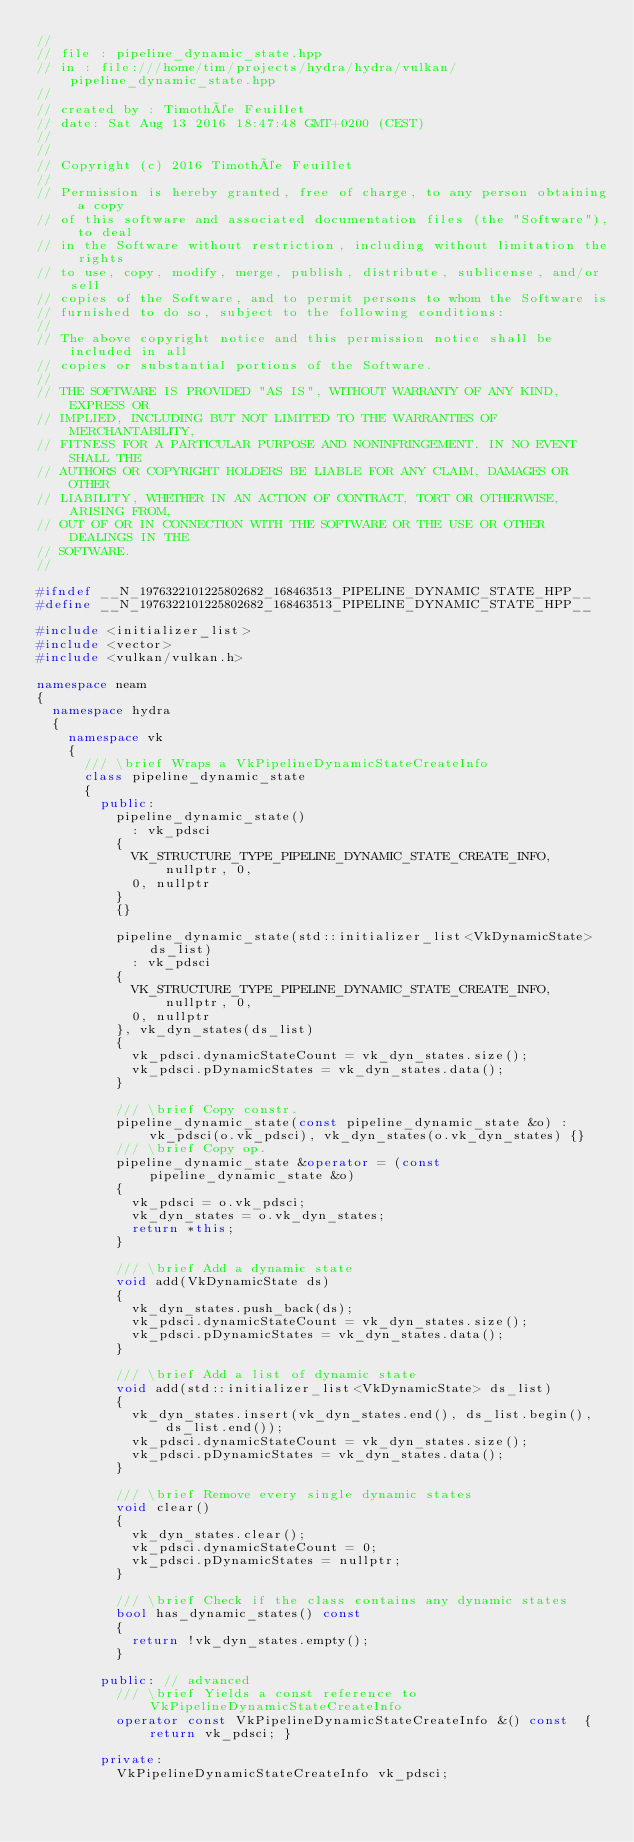Convert code to text. <code><loc_0><loc_0><loc_500><loc_500><_C++_>//
// file : pipeline_dynamic_state.hpp
// in : file:///home/tim/projects/hydra/hydra/vulkan/pipeline_dynamic_state.hpp
//
// created by : Timothée Feuillet
// date: Sat Aug 13 2016 18:47:48 GMT+0200 (CEST)
//
//
// Copyright (c) 2016 Timothée Feuillet
//
// Permission is hereby granted, free of charge, to any person obtaining a copy
// of this software and associated documentation files (the "Software"), to deal
// in the Software without restriction, including without limitation the rights
// to use, copy, modify, merge, publish, distribute, sublicense, and/or sell
// copies of the Software, and to permit persons to whom the Software is
// furnished to do so, subject to the following conditions:
//
// The above copyright notice and this permission notice shall be included in all
// copies or substantial portions of the Software.
//
// THE SOFTWARE IS PROVIDED "AS IS", WITHOUT WARRANTY OF ANY KIND, EXPRESS OR
// IMPLIED, INCLUDING BUT NOT LIMITED TO THE WARRANTIES OF MERCHANTABILITY,
// FITNESS FOR A PARTICULAR PURPOSE AND NONINFRINGEMENT. IN NO EVENT SHALL THE
// AUTHORS OR COPYRIGHT HOLDERS BE LIABLE FOR ANY CLAIM, DAMAGES OR OTHER
// LIABILITY, WHETHER IN AN ACTION OF CONTRACT, TORT OR OTHERWISE, ARISING FROM,
// OUT OF OR IN CONNECTION WITH THE SOFTWARE OR THE USE OR OTHER DEALINGS IN THE
// SOFTWARE.
//

#ifndef __N_1976322101225802682_168463513_PIPELINE_DYNAMIC_STATE_HPP__
#define __N_1976322101225802682_168463513_PIPELINE_DYNAMIC_STATE_HPP__

#include <initializer_list>
#include <vector>
#include <vulkan/vulkan.h>

namespace neam
{
  namespace hydra
  {
    namespace vk
    {
      /// \brief Wraps a VkPipelineDynamicStateCreateInfo
      class pipeline_dynamic_state
      {
        public:
          pipeline_dynamic_state()
            : vk_pdsci
          {
            VK_STRUCTURE_TYPE_PIPELINE_DYNAMIC_STATE_CREATE_INFO, nullptr, 0,
            0, nullptr
          }
          {}

          pipeline_dynamic_state(std::initializer_list<VkDynamicState> ds_list)
            : vk_pdsci
          {
            VK_STRUCTURE_TYPE_PIPELINE_DYNAMIC_STATE_CREATE_INFO, nullptr, 0,
            0, nullptr
          }, vk_dyn_states(ds_list)
          {
            vk_pdsci.dynamicStateCount = vk_dyn_states.size();
            vk_pdsci.pDynamicStates = vk_dyn_states.data();
          }

          /// \brief Copy constr.
          pipeline_dynamic_state(const pipeline_dynamic_state &o) : vk_pdsci(o.vk_pdsci), vk_dyn_states(o.vk_dyn_states) {}
          /// \brief Copy op.
          pipeline_dynamic_state &operator = (const pipeline_dynamic_state &o)
          {
            vk_pdsci = o.vk_pdsci;
            vk_dyn_states = o.vk_dyn_states;
            return *this;
          }

          /// \brief Add a dynamic state
          void add(VkDynamicState ds)
          {
            vk_dyn_states.push_back(ds);
            vk_pdsci.dynamicStateCount = vk_dyn_states.size();
            vk_pdsci.pDynamicStates = vk_dyn_states.data();
          }

          /// \brief Add a list of dynamic state
          void add(std::initializer_list<VkDynamicState> ds_list)
          {
            vk_dyn_states.insert(vk_dyn_states.end(), ds_list.begin(), ds_list.end());
            vk_pdsci.dynamicStateCount = vk_dyn_states.size();
            vk_pdsci.pDynamicStates = vk_dyn_states.data();
          }

          /// \brief Remove every single dynamic states
          void clear()
          {
            vk_dyn_states.clear();
            vk_pdsci.dynamicStateCount = 0;
            vk_pdsci.pDynamicStates = nullptr;
          }

          /// \brief Check if the class contains any dynamic states
          bool has_dynamic_states() const
          {
            return !vk_dyn_states.empty();
          }

        public: // advanced
          /// \brief Yields a const reference to VkPipelineDynamicStateCreateInfo
          operator const VkPipelineDynamicStateCreateInfo &() const  { return vk_pdsci; }

        private:
          VkPipelineDynamicStateCreateInfo vk_pdsci;</code> 